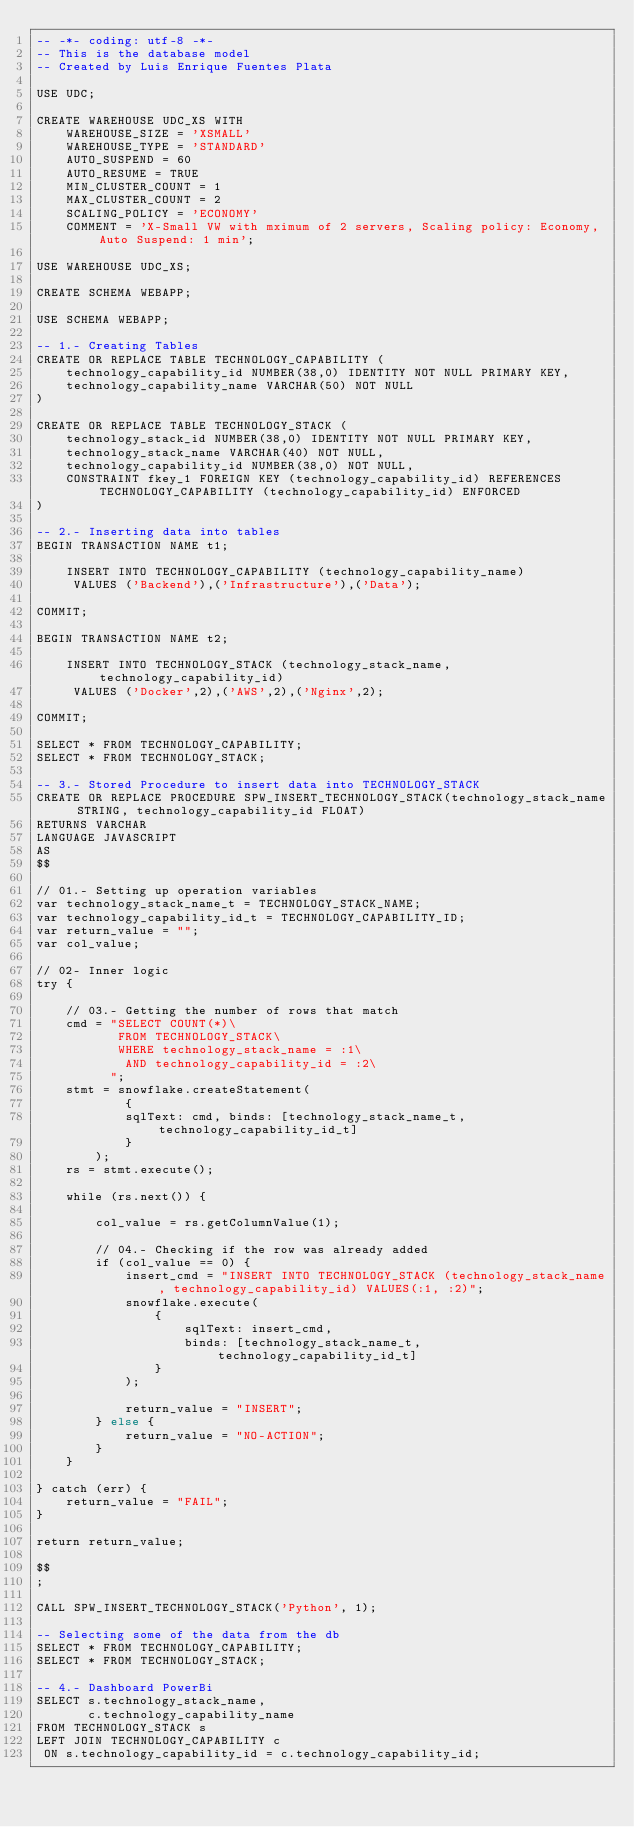<code> <loc_0><loc_0><loc_500><loc_500><_SQL_>-- -*- coding: utf-8 -*-
-- This is the database model
-- Created by Luis Enrique Fuentes Plata

USE UDC;

CREATE WAREHOUSE UDC_XS WITH 
    WAREHOUSE_SIZE = 'XSMALL' 
    WAREHOUSE_TYPE = 'STANDARD' 
    AUTO_SUSPEND = 60 
    AUTO_RESUME = TRUE 
    MIN_CLUSTER_COUNT = 1 
    MAX_CLUSTER_COUNT = 2 
    SCALING_POLICY = 'ECONOMY' 
    COMMENT = 'X-Small VW with mximum of 2 servers, Scaling policy: Economy, Auto Suspend: 1 min';

USE WAREHOUSE UDC_XS;

CREATE SCHEMA WEBAPP;

USE SCHEMA WEBAPP;

-- 1.- Creating Tables
CREATE OR REPLACE TABLE TECHNOLOGY_CAPABILITY (
    technology_capability_id NUMBER(38,0) IDENTITY NOT NULL PRIMARY KEY,
    technology_capability_name VARCHAR(50) NOT NULL
)

CREATE OR REPLACE TABLE TECHNOLOGY_STACK (
    technology_stack_id NUMBER(38,0) IDENTITY NOT NULL PRIMARY KEY,
    technology_stack_name VARCHAR(40) NOT NULL,
    technology_capability_id NUMBER(38,0) NOT NULL,
    CONSTRAINT fkey_1 FOREIGN KEY (technology_capability_id) REFERENCES TECHNOLOGY_CAPABILITY (technology_capability_id) ENFORCED
)

-- 2.- Inserting data into tables
BEGIN TRANSACTION NAME t1;

    INSERT INTO TECHNOLOGY_CAPABILITY (technology_capability_name) 
     VALUES ('Backend'),('Infrastructure'),('Data');
    
COMMIT;

BEGIN TRANSACTION NAME t2;

    INSERT INTO TECHNOLOGY_STACK (technology_stack_name, technology_capability_id) 
     VALUES ('Docker',2),('AWS',2),('Nginx',2);
    
COMMIT;

SELECT * FROM TECHNOLOGY_CAPABILITY;
SELECT * FROM TECHNOLOGY_STACK;

-- 3.- Stored Procedure to insert data into TECHNOLOGY_STACK
CREATE OR REPLACE PROCEDURE SPW_INSERT_TECHNOLOGY_STACK(technology_stack_name STRING, technology_capability_id FLOAT)
RETURNS VARCHAR
LANGUAGE JAVASCRIPT
AS
$$

// 01.- Setting up operation variables
var technology_stack_name_t = TECHNOLOGY_STACK_NAME;
var technology_capability_id_t = TECHNOLOGY_CAPABILITY_ID;
var return_value = "";
var col_value;

// 02- Inner logic
try {

    // 03.- Getting the number of rows that match
    cmd = "SELECT COUNT(*)\
           FROM TECHNOLOGY_STACK\
           WHERE technology_stack_name = :1\
            AND technology_capability_id = :2\
          ";
    stmt = snowflake.createStatement(
            {
            sqlText: cmd, binds: [technology_stack_name_t, technology_capability_id_t]
            }
        );
    rs = stmt.execute();

    while (rs.next()) {

        col_value = rs.getColumnValue(1);

        // 04.- Checking if the row was already added
        if (col_value == 0) {
            insert_cmd = "INSERT INTO TECHNOLOGY_STACK (technology_stack_name, technology_capability_id) VALUES(:1, :2)";
            snowflake.execute(
                {
                    sqlText: insert_cmd,
                    binds: [technology_stack_name_t, technology_capability_id_t]
                }
            );
            
            return_value = "INSERT";
        } else {
            return_value = "NO-ACTION";
        }
    }

} catch (err) {
    return_value = "FAIL";
}

return return_value;

$$
;

CALL SPW_INSERT_TECHNOLOGY_STACK('Python', 1);

-- Selecting some of the data from the db
SELECT * FROM TECHNOLOGY_CAPABILITY;
SELECT * FROM TECHNOLOGY_STACK;

-- 4.- Dashboard PowerBi
SELECT s.technology_stack_name,
       c.technology_capability_name
FROM TECHNOLOGY_STACK s
LEFT JOIN TECHNOLOGY_CAPABILITY c
 ON s.technology_capability_id = c.technology_capability_id;
 
</code> 